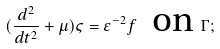Convert formula to latex. <formula><loc_0><loc_0><loc_500><loc_500>( \frac { d ^ { 2 } } { d t ^ { 2 } } + \mu ) \varsigma = \varepsilon ^ { - 2 } f \text { \ on } \Gamma ;</formula> 